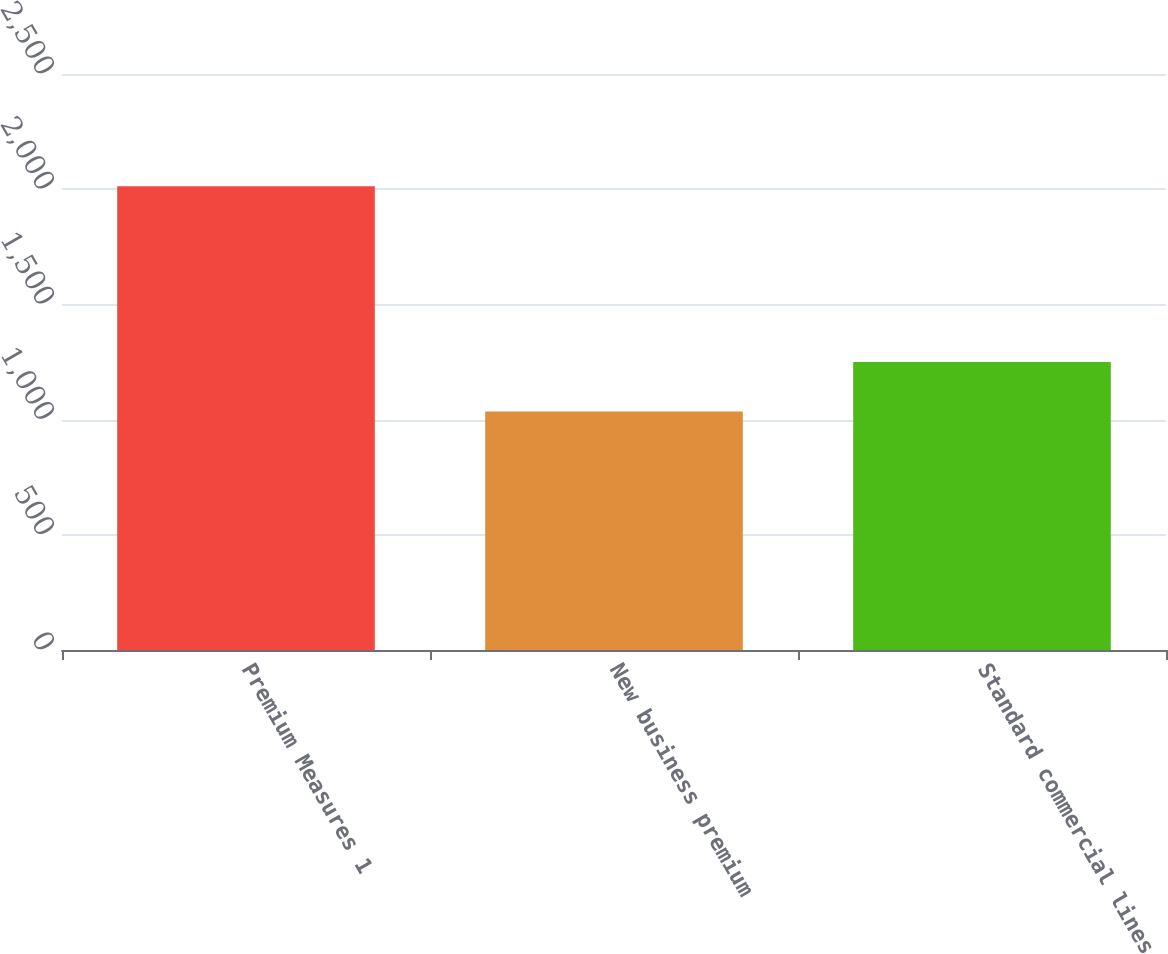<chart> <loc_0><loc_0><loc_500><loc_500><bar_chart><fcel>Premium Measures 1<fcel>New business premium<fcel>Standard commercial lines<nl><fcel>2013<fcel>1035<fcel>1250<nl></chart> 